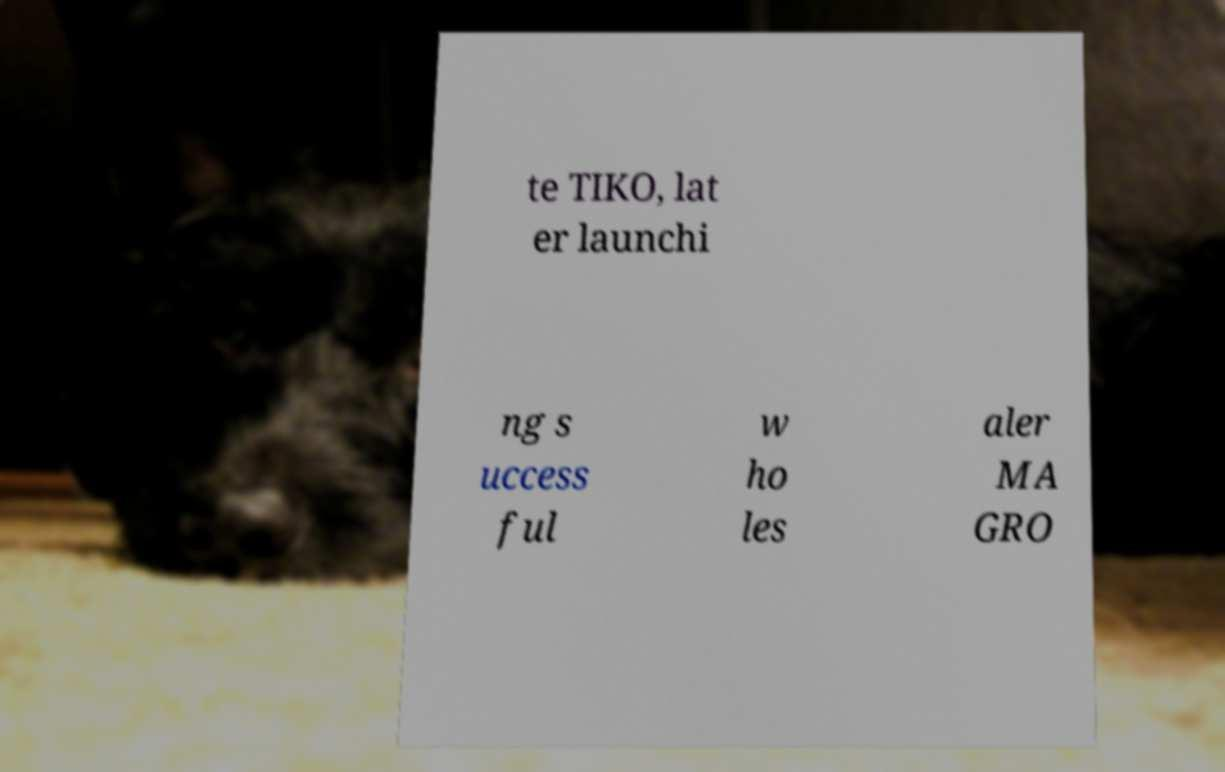Could you extract and type out the text from this image? te TIKO, lat er launchi ng s uccess ful w ho les aler MA GRO 